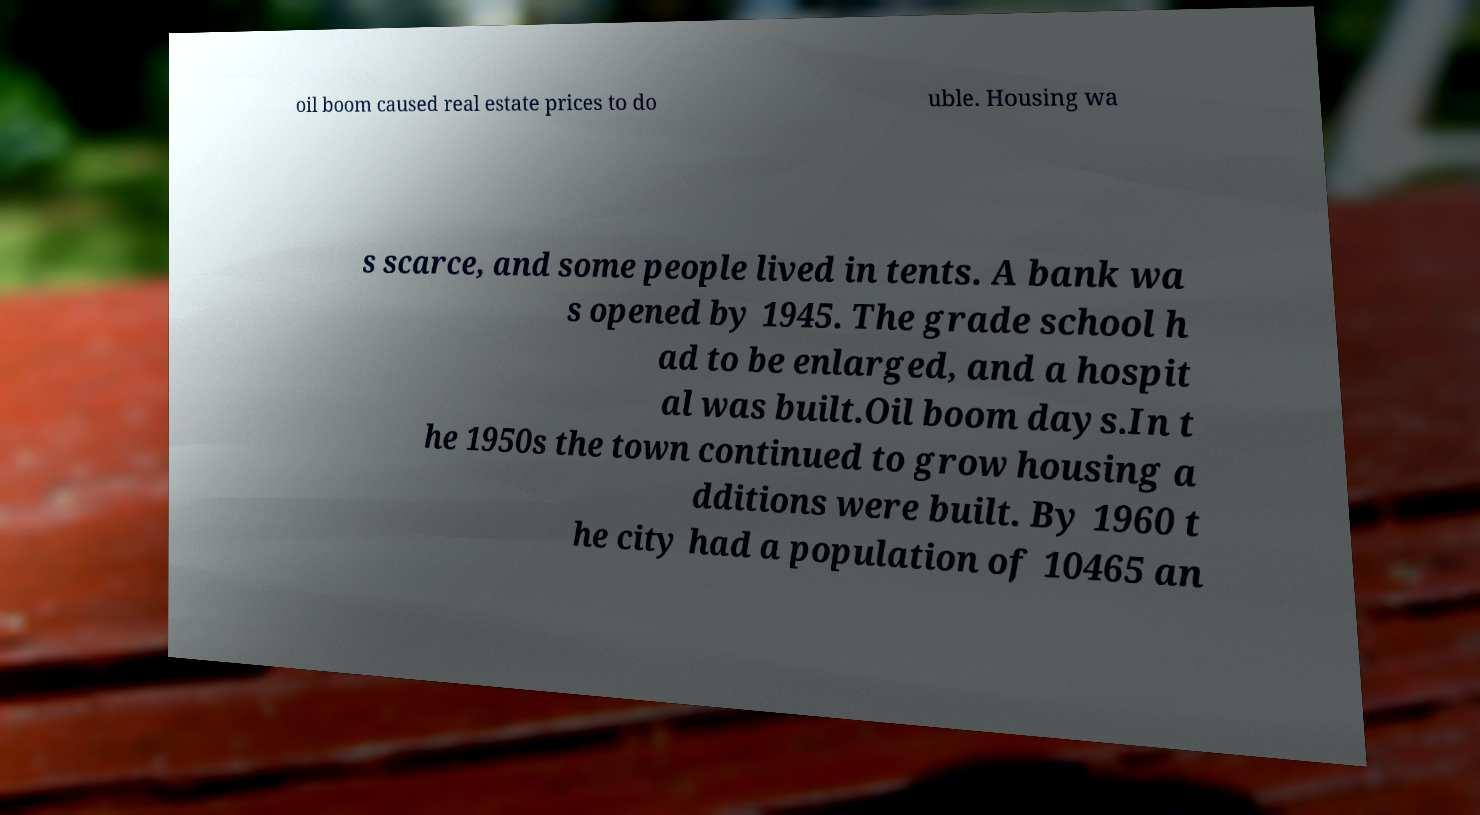Please read and relay the text visible in this image. What does it say? oil boom caused real estate prices to do uble. Housing wa s scarce, and some people lived in tents. A bank wa s opened by 1945. The grade school h ad to be enlarged, and a hospit al was built.Oil boom days.In t he 1950s the town continued to grow housing a dditions were built. By 1960 t he city had a population of 10465 an 